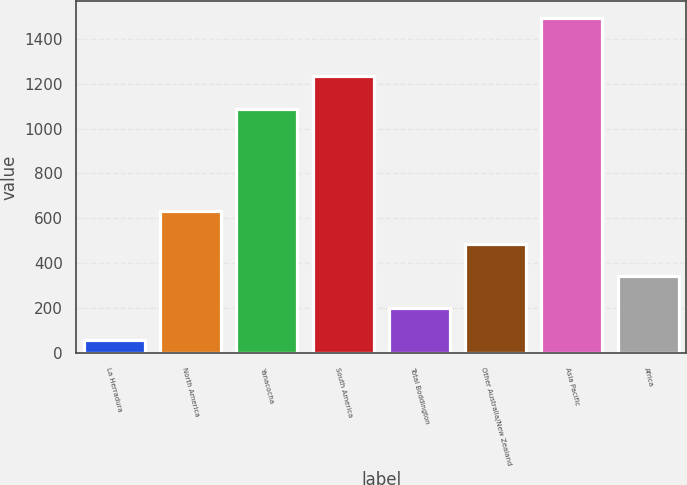<chart> <loc_0><loc_0><loc_500><loc_500><bar_chart><fcel>La Herradura<fcel>North America<fcel>Yanacocha<fcel>South America<fcel>Total Boddington<fcel>Other Australia/New Zealand<fcel>Asia Pacific<fcel>Africa<nl><fcel>57<fcel>631<fcel>1089<fcel>1232.5<fcel>200.5<fcel>487.5<fcel>1492<fcel>344<nl></chart> 